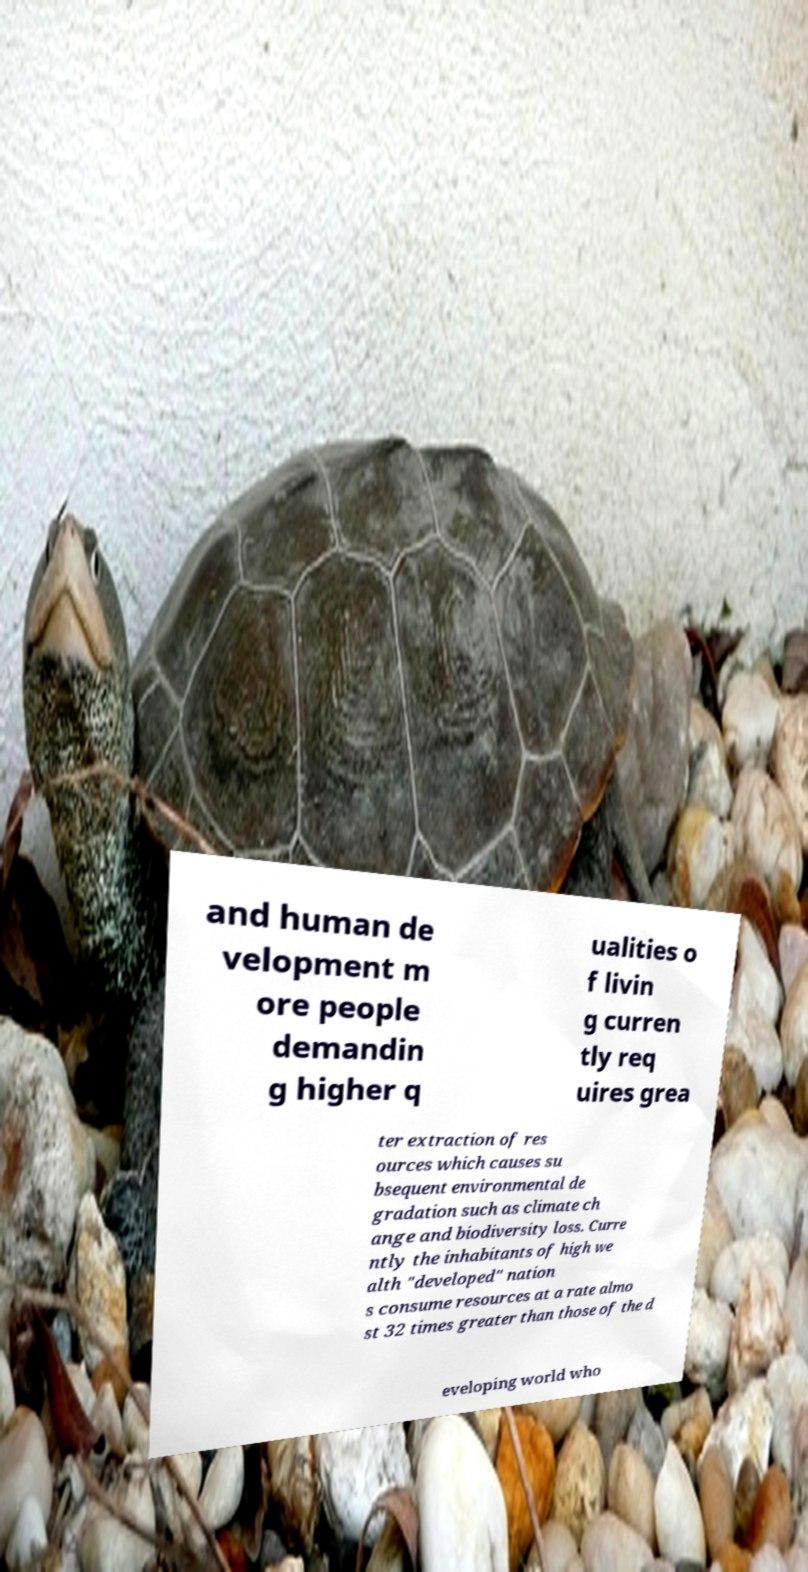What messages or text are displayed in this image? I need them in a readable, typed format. and human de velopment m ore people demandin g higher q ualities o f livin g curren tly req uires grea ter extraction of res ources which causes su bsequent environmental de gradation such as climate ch ange and biodiversity loss. Curre ntly the inhabitants of high we alth "developed" nation s consume resources at a rate almo st 32 times greater than those of the d eveloping world who 